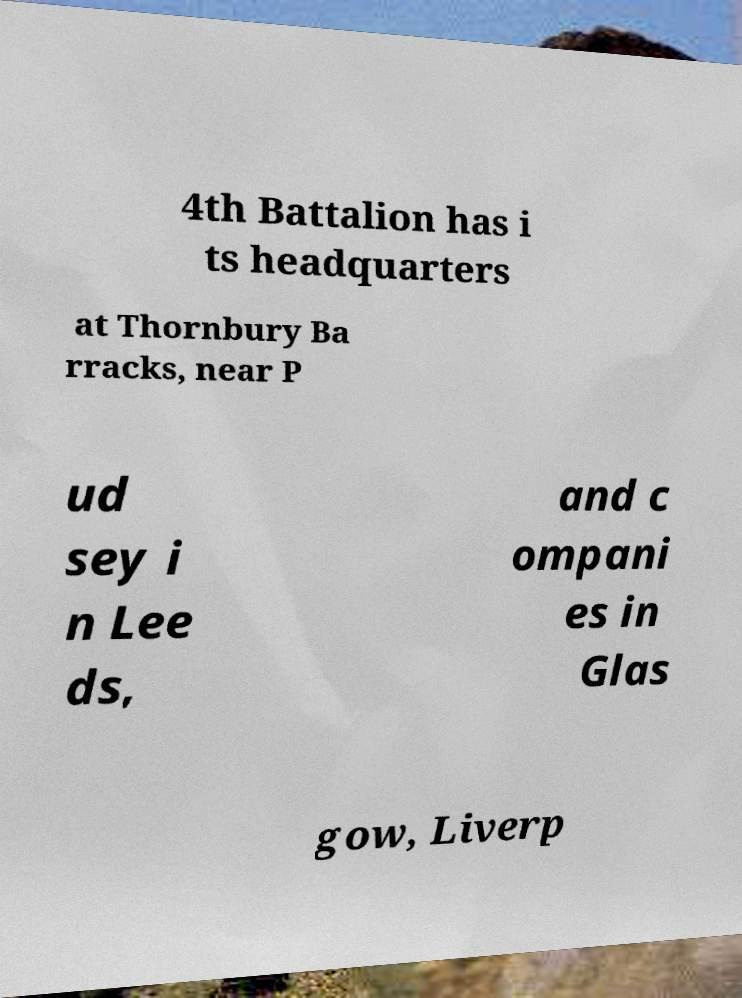Please identify and transcribe the text found in this image. 4th Battalion has i ts headquarters at Thornbury Ba rracks, near P ud sey i n Lee ds, and c ompani es in Glas gow, Liverp 